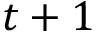Convert formula to latex. <formula><loc_0><loc_0><loc_500><loc_500>t + 1</formula> 